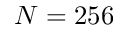Convert formula to latex. <formula><loc_0><loc_0><loc_500><loc_500>N = 2 5 6</formula> 